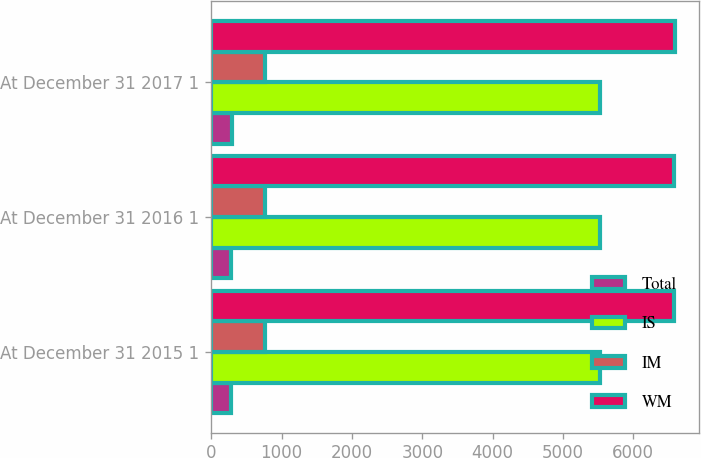Convert chart. <chart><loc_0><loc_0><loc_500><loc_500><stacked_bar_chart><ecel><fcel>At December 31 2015 1<fcel>At December 31 2016 1<fcel>At December 31 2017 1<nl><fcel>Total<fcel>282<fcel>275<fcel>295<nl><fcel>IS<fcel>5533<fcel>5533<fcel>5533<nl><fcel>IM<fcel>769<fcel>769<fcel>769<nl><fcel>WM<fcel>6584<fcel>6577<fcel>6597<nl></chart> 